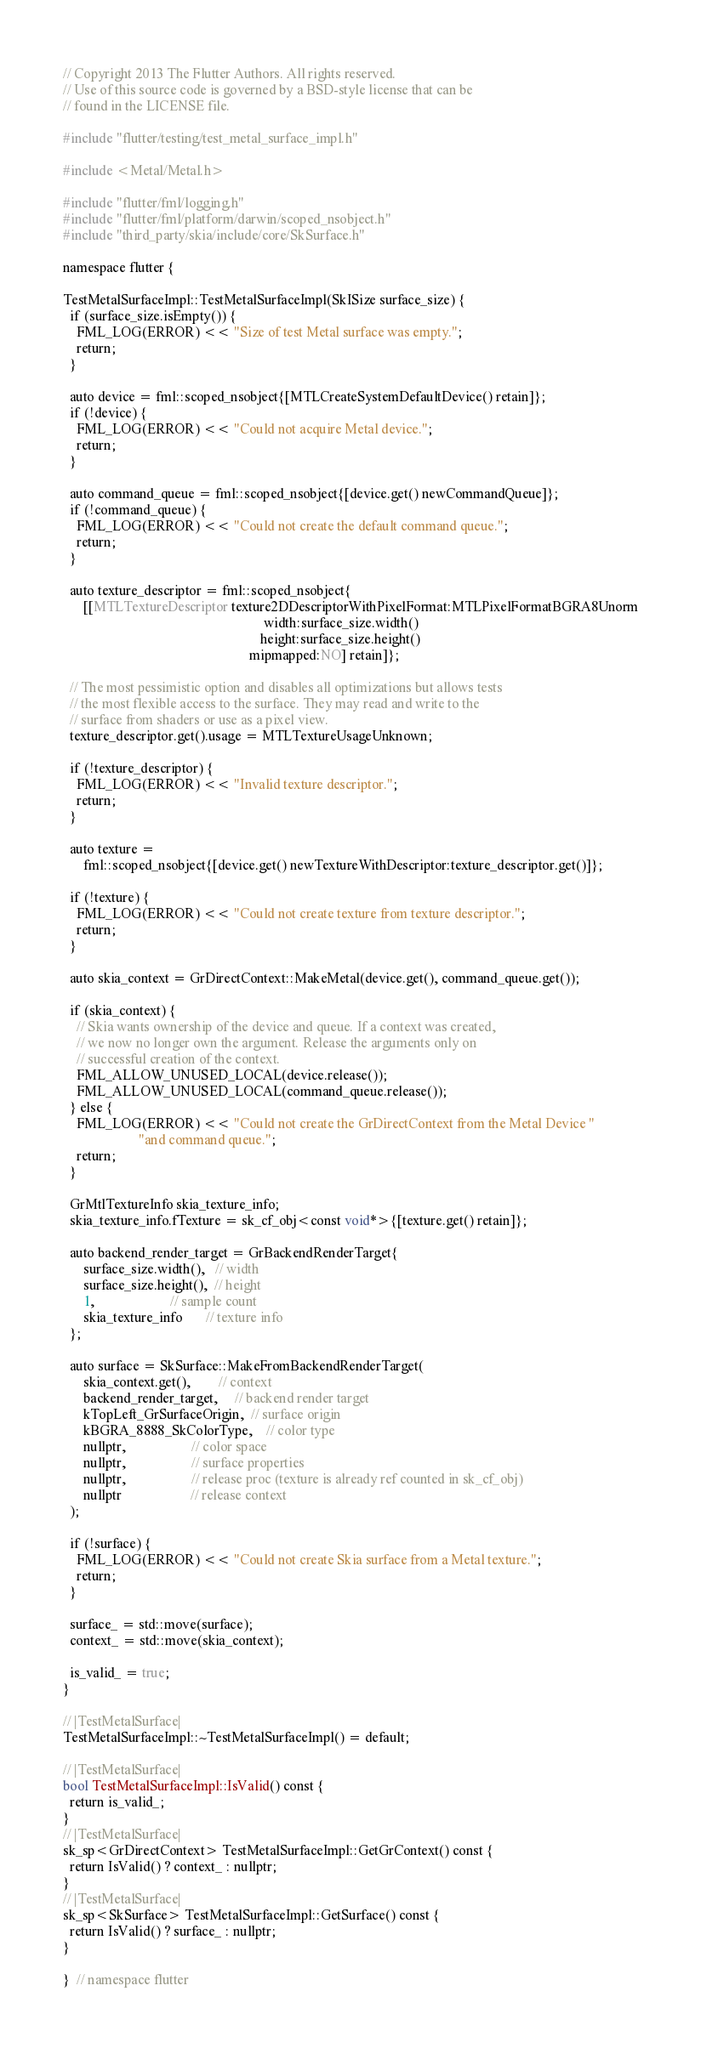<code> <loc_0><loc_0><loc_500><loc_500><_ObjectiveC_>// Copyright 2013 The Flutter Authors. All rights reserved.
// Use of this source code is governed by a BSD-style license that can be
// found in the LICENSE file.

#include "flutter/testing/test_metal_surface_impl.h"

#include <Metal/Metal.h>

#include "flutter/fml/logging.h"
#include "flutter/fml/platform/darwin/scoped_nsobject.h"
#include "third_party/skia/include/core/SkSurface.h"

namespace flutter {

TestMetalSurfaceImpl::TestMetalSurfaceImpl(SkISize surface_size) {
  if (surface_size.isEmpty()) {
    FML_LOG(ERROR) << "Size of test Metal surface was empty.";
    return;
  }

  auto device = fml::scoped_nsobject{[MTLCreateSystemDefaultDevice() retain]};
  if (!device) {
    FML_LOG(ERROR) << "Could not acquire Metal device.";
    return;
  }

  auto command_queue = fml::scoped_nsobject{[device.get() newCommandQueue]};
  if (!command_queue) {
    FML_LOG(ERROR) << "Could not create the default command queue.";
    return;
  }

  auto texture_descriptor = fml::scoped_nsobject{
      [[MTLTextureDescriptor texture2DDescriptorWithPixelFormat:MTLPixelFormatBGRA8Unorm
                                                          width:surface_size.width()
                                                         height:surface_size.height()
                                                      mipmapped:NO] retain]};

  // The most pessimistic option and disables all optimizations but allows tests
  // the most flexible access to the surface. They may read and write to the
  // surface from shaders or use as a pixel view.
  texture_descriptor.get().usage = MTLTextureUsageUnknown;

  if (!texture_descriptor) {
    FML_LOG(ERROR) << "Invalid texture descriptor.";
    return;
  }

  auto texture =
      fml::scoped_nsobject{[device.get() newTextureWithDescriptor:texture_descriptor.get()]};

  if (!texture) {
    FML_LOG(ERROR) << "Could not create texture from texture descriptor.";
    return;
  }

  auto skia_context = GrDirectContext::MakeMetal(device.get(), command_queue.get());

  if (skia_context) {
    // Skia wants ownership of the device and queue. If a context was created,
    // we now no longer own the argument. Release the arguments only on
    // successful creation of the context.
    FML_ALLOW_UNUSED_LOCAL(device.release());
    FML_ALLOW_UNUSED_LOCAL(command_queue.release());
  } else {
    FML_LOG(ERROR) << "Could not create the GrDirectContext from the Metal Device "
                      "and command queue.";
    return;
  }

  GrMtlTextureInfo skia_texture_info;
  skia_texture_info.fTexture = sk_cf_obj<const void*>{[texture.get() retain]};

  auto backend_render_target = GrBackendRenderTarget{
      surface_size.width(),   // width
      surface_size.height(),  // height
      1,                      // sample count
      skia_texture_info       // texture info
  };

  auto surface = SkSurface::MakeFromBackendRenderTarget(
      skia_context.get(),        // context
      backend_render_target,     // backend render target
      kTopLeft_GrSurfaceOrigin,  // surface origin
      kBGRA_8888_SkColorType,    // color type
      nullptr,                   // color space
      nullptr,                   // surface properties
      nullptr,                   // release proc (texture is already ref counted in sk_cf_obj)
      nullptr                    // release context
  );

  if (!surface) {
    FML_LOG(ERROR) << "Could not create Skia surface from a Metal texture.";
    return;
  }

  surface_ = std::move(surface);
  context_ = std::move(skia_context);

  is_valid_ = true;
}

// |TestMetalSurface|
TestMetalSurfaceImpl::~TestMetalSurfaceImpl() = default;

// |TestMetalSurface|
bool TestMetalSurfaceImpl::IsValid() const {
  return is_valid_;
}
// |TestMetalSurface|
sk_sp<GrDirectContext> TestMetalSurfaceImpl::GetGrContext() const {
  return IsValid() ? context_ : nullptr;
}
// |TestMetalSurface|
sk_sp<SkSurface> TestMetalSurfaceImpl::GetSurface() const {
  return IsValid() ? surface_ : nullptr;
}

}  // namespace flutter
</code> 